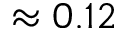<formula> <loc_0><loc_0><loc_500><loc_500>\approx 0 . 1 2</formula> 